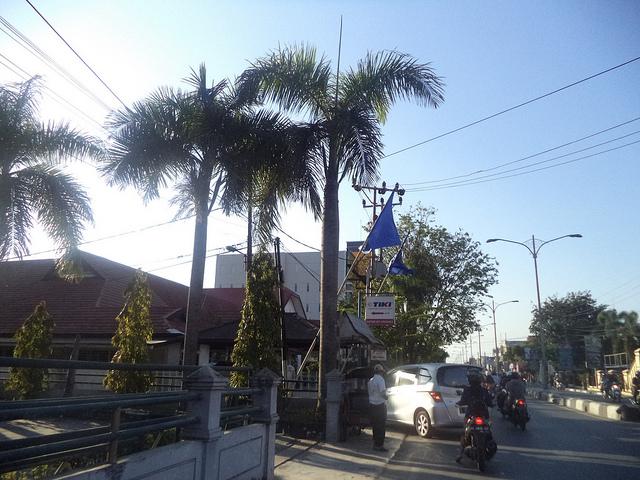What types of trees are in the center of the picture?
Be succinct. Palm. Is this a palm tree?
Be succinct. Yes. Is the driver of the car trying to find a parking spot?
Give a very brief answer. Yes. 